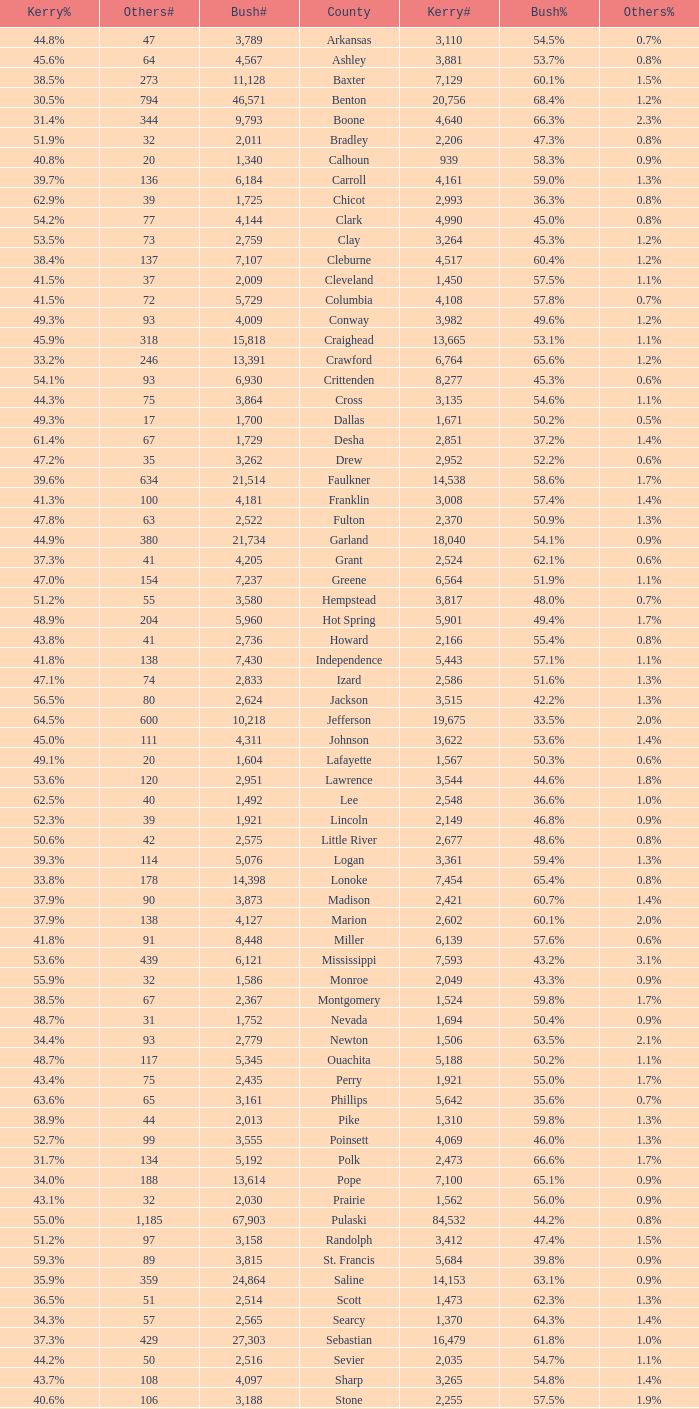What is the lowest Kerry#, when Others# is "106", and when Bush# is less than 3,188? None. 